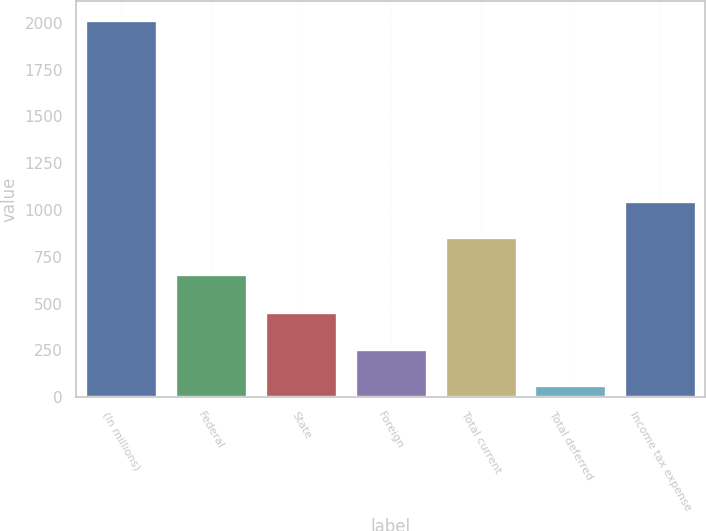<chart> <loc_0><loc_0><loc_500><loc_500><bar_chart><fcel>(In millions)<fcel>Federal<fcel>State<fcel>Foreign<fcel>Total current<fcel>Total deferred<fcel>Income tax expense<nl><fcel>2016<fcel>658<fcel>454.4<fcel>259.2<fcel>853.2<fcel>64<fcel>1048.4<nl></chart> 